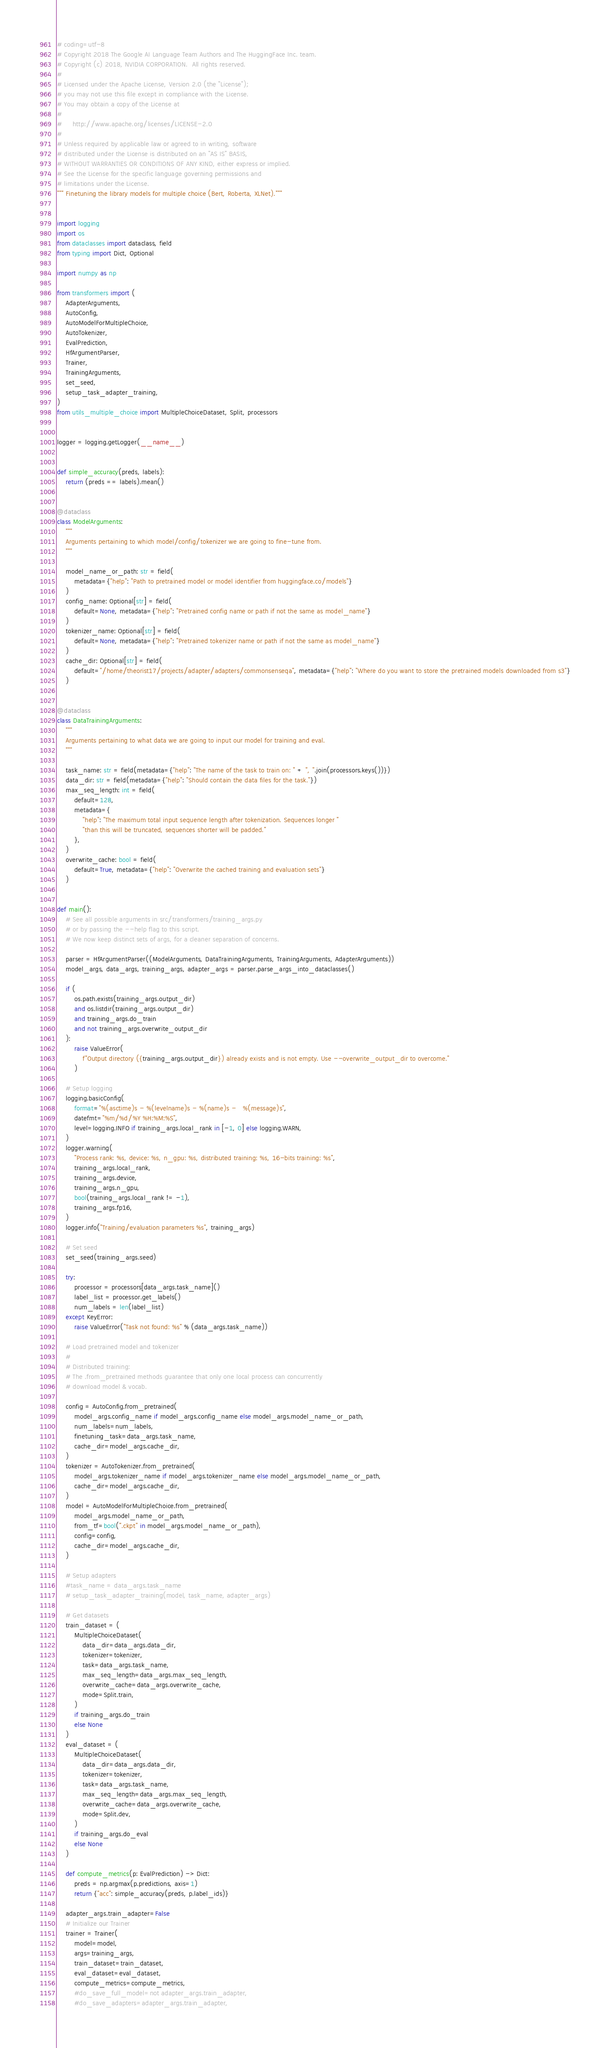Convert code to text. <code><loc_0><loc_0><loc_500><loc_500><_Python_># coding=utf-8
# Copyright 2018 The Google AI Language Team Authors and The HuggingFace Inc. team.
# Copyright (c) 2018, NVIDIA CORPORATION.  All rights reserved.
#
# Licensed under the Apache License, Version 2.0 (the "License");
# you may not use this file except in compliance with the License.
# You may obtain a copy of the License at
#
#     http://www.apache.org/licenses/LICENSE-2.0
#
# Unless required by applicable law or agreed to in writing, software
# distributed under the License is distributed on an "AS IS" BASIS,
# WITHOUT WARRANTIES OR CONDITIONS OF ANY KIND, either express or implied.
# See the License for the specific language governing permissions and
# limitations under the License.
""" Finetuning the library models for multiple choice (Bert, Roberta, XLNet)."""


import logging
import os
from dataclasses import dataclass, field
from typing import Dict, Optional

import numpy as np

from transformers import (
    AdapterArguments,
    AutoConfig,
    AutoModelForMultipleChoice,
    AutoTokenizer,
    EvalPrediction,
    HfArgumentParser,
    Trainer,
    TrainingArguments,
    set_seed,
    setup_task_adapter_training,
)
from utils_multiple_choice import MultipleChoiceDataset, Split, processors


logger = logging.getLogger(__name__)


def simple_accuracy(preds, labels):
    return (preds == labels).mean()


@dataclass
class ModelArguments:
    """
    Arguments pertaining to which model/config/tokenizer we are going to fine-tune from.
    """

    model_name_or_path: str = field(
        metadata={"help": "Path to pretrained model or model identifier from huggingface.co/models"}
    )
    config_name: Optional[str] = field(
        default=None, metadata={"help": "Pretrained config name or path if not the same as model_name"}
    )
    tokenizer_name: Optional[str] = field(
        default=None, metadata={"help": "Pretrained tokenizer name or path if not the same as model_name"}
    )
    cache_dir: Optional[str] = field(
        default="/home/theorist17/projects/adapter/adapters/commonsenseqa", metadata={"help": "Where do you want to store the pretrained models downloaded from s3"}
    )


@dataclass
class DataTrainingArguments:
    """
    Arguments pertaining to what data we are going to input our model for training and eval.
    """

    task_name: str = field(metadata={"help": "The name of the task to train on: " + ", ".join(processors.keys())})
    data_dir: str = field(metadata={"help": "Should contain the data files for the task."})
    max_seq_length: int = field(
        default=128,
        metadata={
            "help": "The maximum total input sequence length after tokenization. Sequences longer "
            "than this will be truncated, sequences shorter will be padded."
        },
    )
    overwrite_cache: bool = field(
        default=True, metadata={"help": "Overwrite the cached training and evaluation sets"}
    )


def main():
    # See all possible arguments in src/transformers/training_args.py
    # or by passing the --help flag to this script.
    # We now keep distinct sets of args, for a cleaner separation of concerns.

    parser = HfArgumentParser((ModelArguments, DataTrainingArguments, TrainingArguments, AdapterArguments))
    model_args, data_args, training_args, adapter_args = parser.parse_args_into_dataclasses()

    if (
        os.path.exists(training_args.output_dir)
        and os.listdir(training_args.output_dir)
        and training_args.do_train
        and not training_args.overwrite_output_dir
    ):
        raise ValueError(
            f"Output directory ({training_args.output_dir}) already exists and is not empty. Use --overwrite_output_dir to overcome."
        )

    # Setup logging
    logging.basicConfig(
        format="%(asctime)s - %(levelname)s - %(name)s -   %(message)s",
        datefmt="%m/%d/%Y %H:%M:%S",
        level=logging.INFO if training_args.local_rank in [-1, 0] else logging.WARN,
    )
    logger.warning(
        "Process rank: %s, device: %s, n_gpu: %s, distributed training: %s, 16-bits training: %s",
        training_args.local_rank,
        training_args.device,
        training_args.n_gpu,
        bool(training_args.local_rank != -1),
        training_args.fp16,
    )
    logger.info("Training/evaluation parameters %s", training_args)

    # Set seed
    set_seed(training_args.seed)

    try:
        processor = processors[data_args.task_name]()
        label_list = processor.get_labels()
        num_labels = len(label_list)
    except KeyError:
        raise ValueError("Task not found: %s" % (data_args.task_name))

    # Load pretrained model and tokenizer
    #
    # Distributed training:
    # The .from_pretrained methods guarantee that only one local process can concurrently
    # download model & vocab.

    config = AutoConfig.from_pretrained(
        model_args.config_name if model_args.config_name else model_args.model_name_or_path,
        num_labels=num_labels,
        finetuning_task=data_args.task_name,
        cache_dir=model_args.cache_dir,
    )
    tokenizer = AutoTokenizer.from_pretrained(
        model_args.tokenizer_name if model_args.tokenizer_name else model_args.model_name_or_path,
        cache_dir=model_args.cache_dir,
    )
    model = AutoModelForMultipleChoice.from_pretrained(
        model_args.model_name_or_path,
        from_tf=bool(".ckpt" in model_args.model_name_or_path),
        config=config,
        cache_dir=model_args.cache_dir,
    )

    # Setup adapters
    #task_name = data_args.task_name
    # setup_task_adapter_training(model, task_name, adapter_args)

    # Get datasets
    train_dataset = (
        MultipleChoiceDataset(
            data_dir=data_args.data_dir,
            tokenizer=tokenizer,
            task=data_args.task_name,
            max_seq_length=data_args.max_seq_length,
            overwrite_cache=data_args.overwrite_cache,
            mode=Split.train,
        )
        if training_args.do_train
        else None
    )
    eval_dataset = (
        MultipleChoiceDataset(
            data_dir=data_args.data_dir,
            tokenizer=tokenizer,
            task=data_args.task_name,
            max_seq_length=data_args.max_seq_length,
            overwrite_cache=data_args.overwrite_cache,
            mode=Split.dev,
        )
        if training_args.do_eval
        else None
    )

    def compute_metrics(p: EvalPrediction) -> Dict:
        preds = np.argmax(p.predictions, axis=1)
        return {"acc": simple_accuracy(preds, p.label_ids)}

    adapter_args.train_adapter=False
    # Initialize our Trainer
    trainer = Trainer(
        model=model,
        args=training_args,
        train_dataset=train_dataset,
        eval_dataset=eval_dataset,
        compute_metrics=compute_metrics,
        #do_save_full_model=not adapter_args.train_adapter,
        #do_save_adapters=adapter_args.train_adapter,</code> 